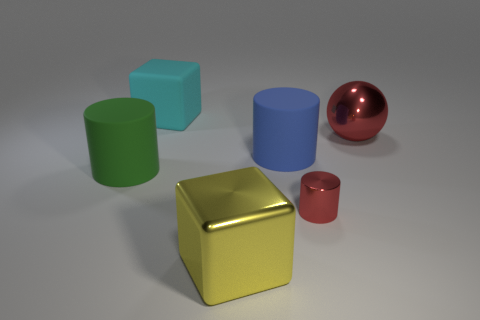Subtract all big cylinders. How many cylinders are left? 1 Add 4 big blocks. How many objects exist? 10 Subtract all cubes. How many objects are left? 4 Subtract all gray rubber cubes. Subtract all cyan things. How many objects are left? 5 Add 5 small red things. How many small red things are left? 6 Add 2 small brown rubber cubes. How many small brown rubber cubes exist? 2 Subtract 1 red balls. How many objects are left? 5 